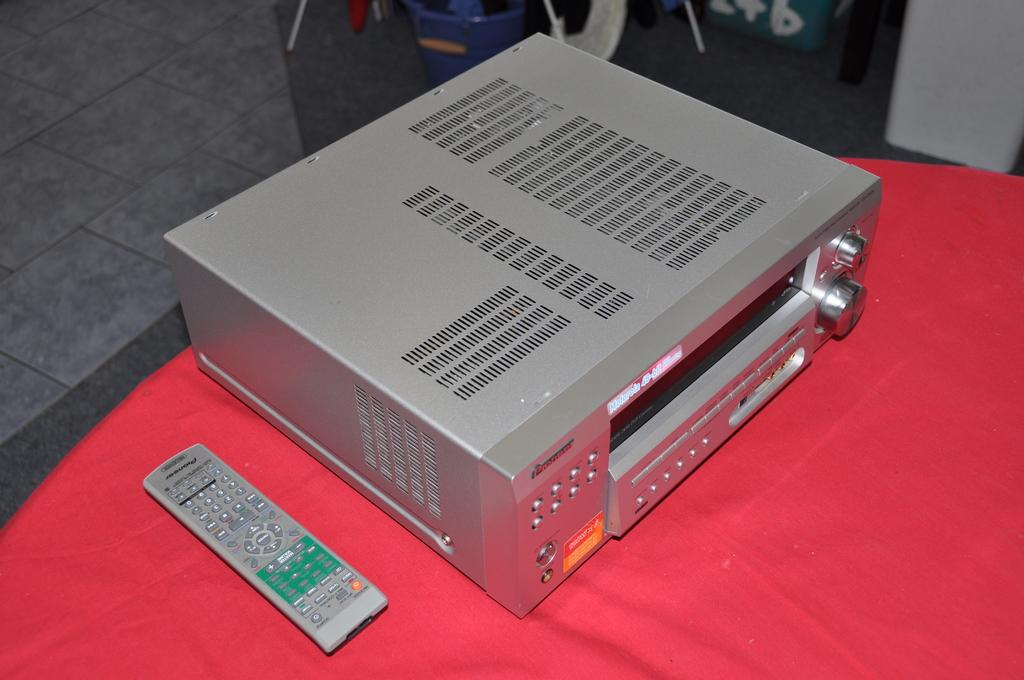What is on the table in the image? There is a device and a remote on the table in the image. What can be seen in the background of the image? There is a wall and objects visible in the background of the image. What is the surface visible beneath the table? There is a floor visible in the image. What type of screw can be seen on the edge of the device in the image? There is no screw visible on the edge of the device in the image. 